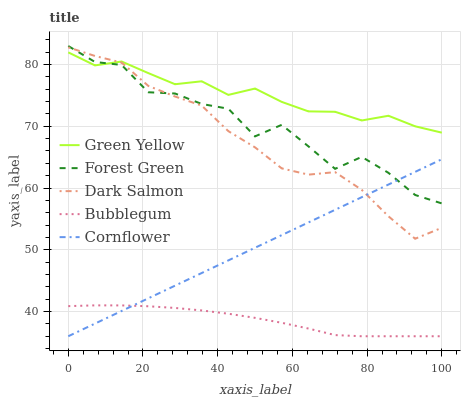Does Forest Green have the minimum area under the curve?
Answer yes or no. No. Does Forest Green have the maximum area under the curve?
Answer yes or no. No. Is Green Yellow the smoothest?
Answer yes or no. No. Is Green Yellow the roughest?
Answer yes or no. No. Does Forest Green have the lowest value?
Answer yes or no. No. Does Green Yellow have the highest value?
Answer yes or no. No. Is Bubblegum less than Dark Salmon?
Answer yes or no. Yes. Is Forest Green greater than Bubblegum?
Answer yes or no. Yes. Does Bubblegum intersect Dark Salmon?
Answer yes or no. No. 